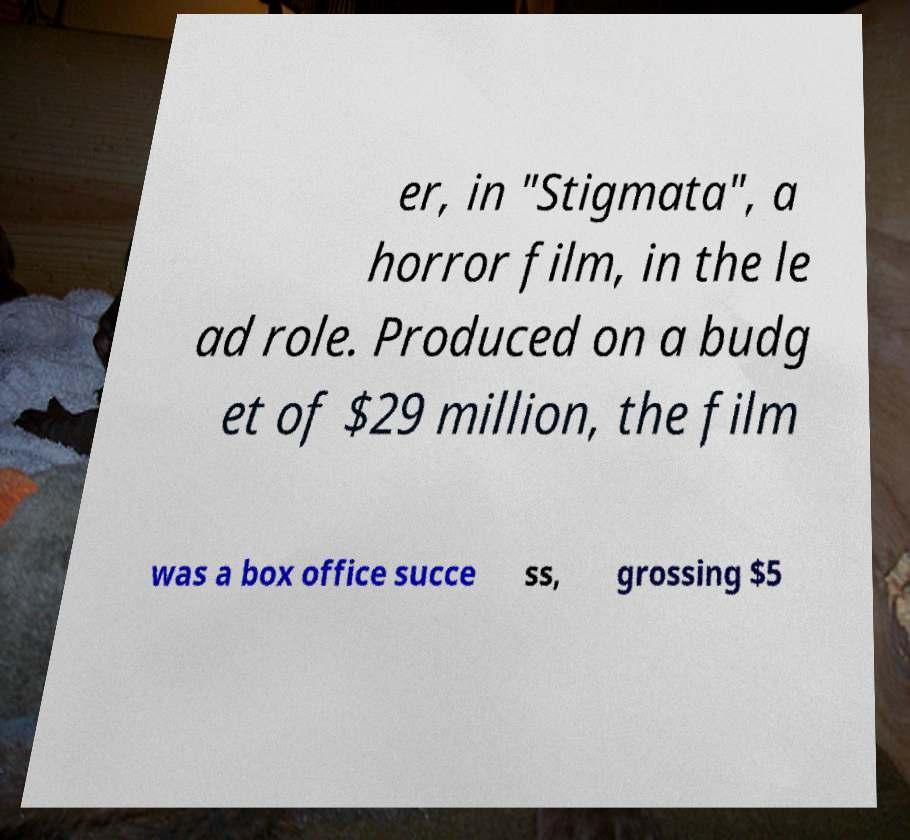Please read and relay the text visible in this image. What does it say? er, in "Stigmata", a horror film, in the le ad role. Produced on a budg et of $29 million, the film was a box office succe ss, grossing $5 